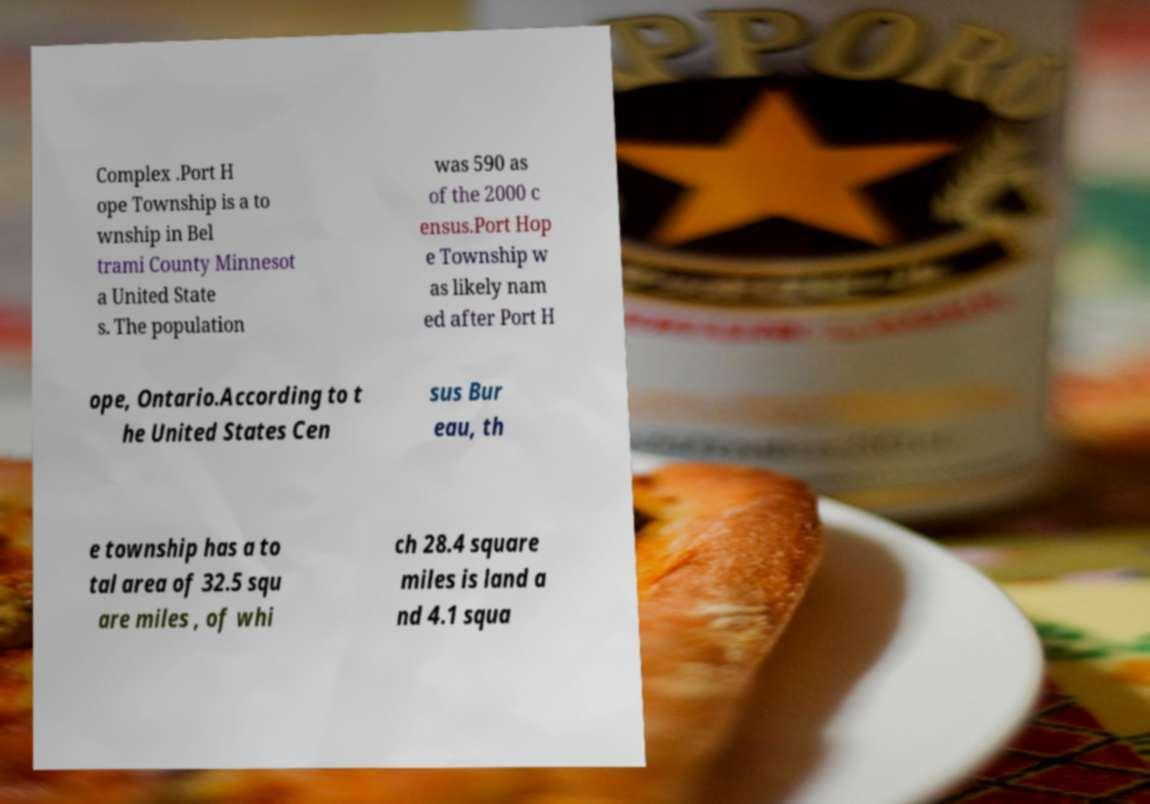Could you assist in decoding the text presented in this image and type it out clearly? Complex .Port H ope Township is a to wnship in Bel trami County Minnesot a United State s. The population was 590 as of the 2000 c ensus.Port Hop e Township w as likely nam ed after Port H ope, Ontario.According to t he United States Cen sus Bur eau, th e township has a to tal area of 32.5 squ are miles , of whi ch 28.4 square miles is land a nd 4.1 squa 